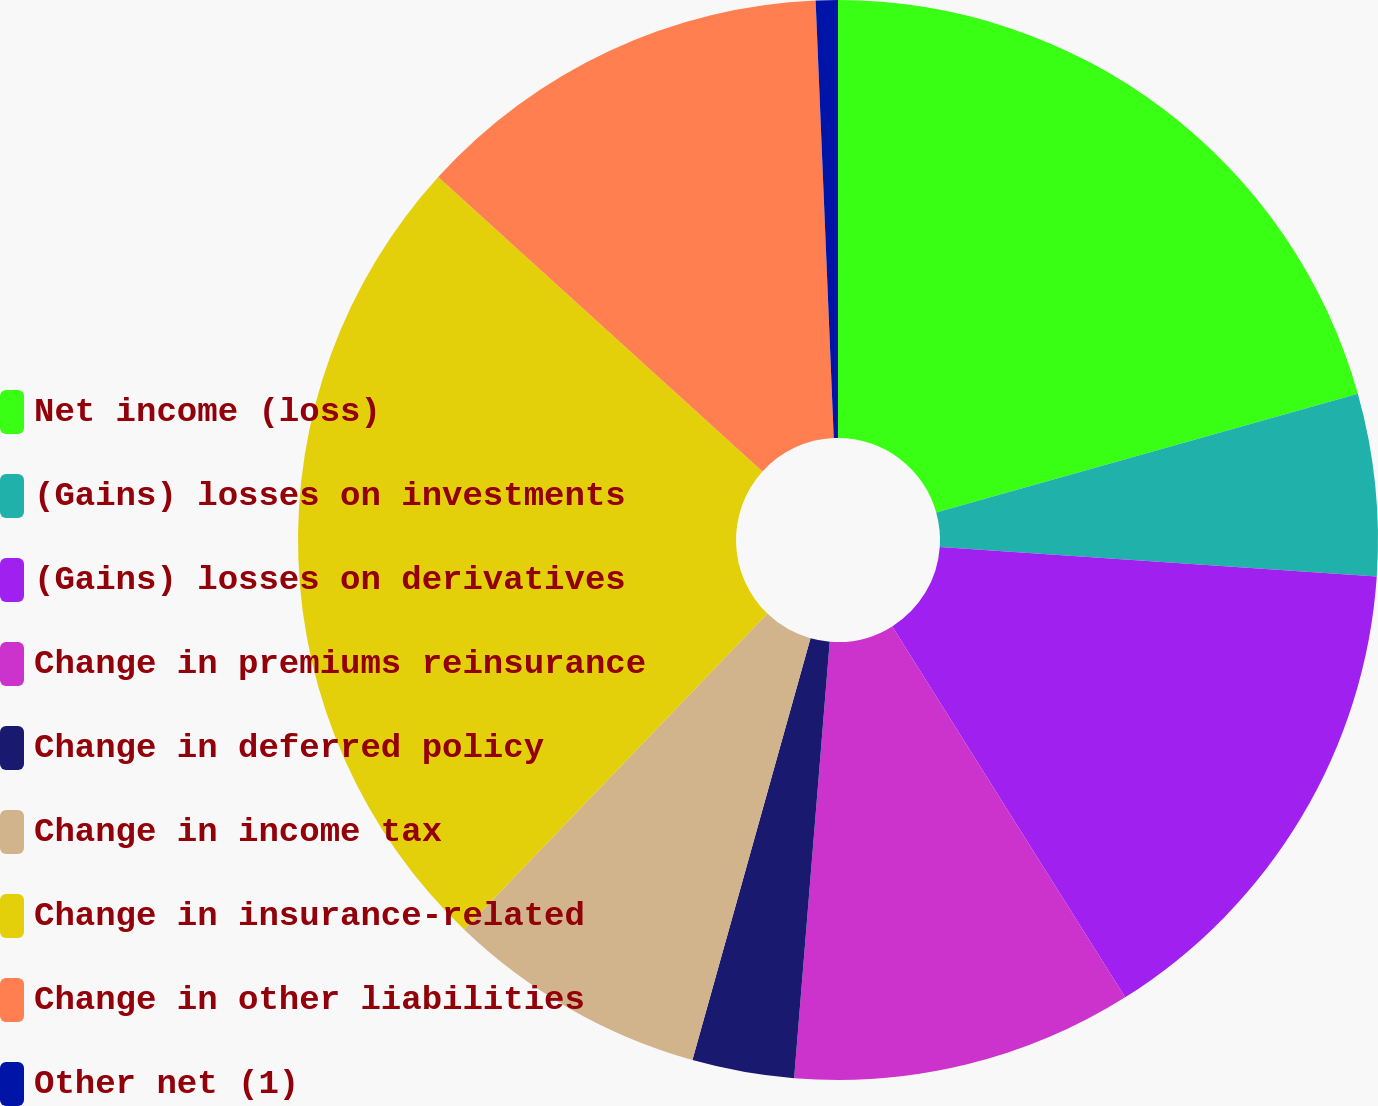Convert chart. <chart><loc_0><loc_0><loc_500><loc_500><pie_chart><fcel>Net income (loss)<fcel>(Gains) losses on investments<fcel>(Gains) losses on derivatives<fcel>Change in premiums reinsurance<fcel>Change in deferred policy<fcel>Change in income tax<fcel>Change in insurance-related<fcel>Change in other liabilities<fcel>Other net (1)<nl><fcel>20.64%<fcel>5.44%<fcel>15.0%<fcel>10.22%<fcel>3.05%<fcel>7.83%<fcel>24.56%<fcel>12.61%<fcel>0.66%<nl></chart> 